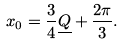Convert formula to latex. <formula><loc_0><loc_0><loc_500><loc_500>x _ { 0 } = \frac { 3 } { 4 } \underline { Q } + \frac { 2 \pi } { 3 } .</formula> 